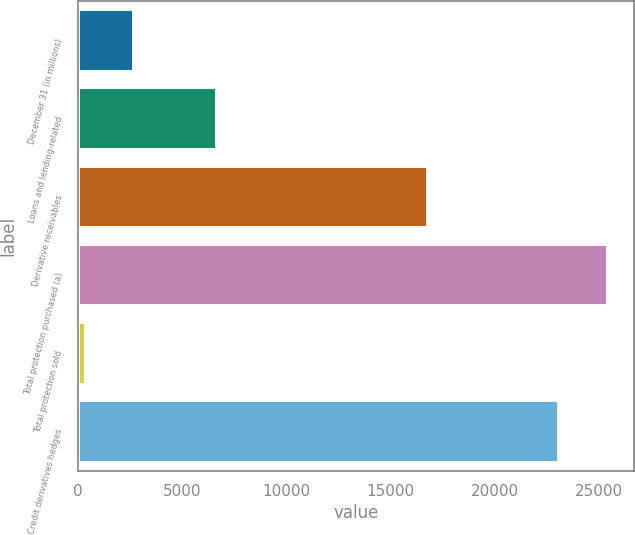Convert chart. <chart><loc_0><loc_0><loc_500><loc_500><bar_chart><fcel>December 31 (in millions)<fcel>Loans and lending-related<fcel>Derivative receivables<fcel>Total protection purchased (a)<fcel>Total protection sold<fcel>Credit derivatives hedges<nl><fcel>2725.8<fcel>6698<fcel>16825<fcel>25418.8<fcel>415<fcel>23108<nl></chart> 